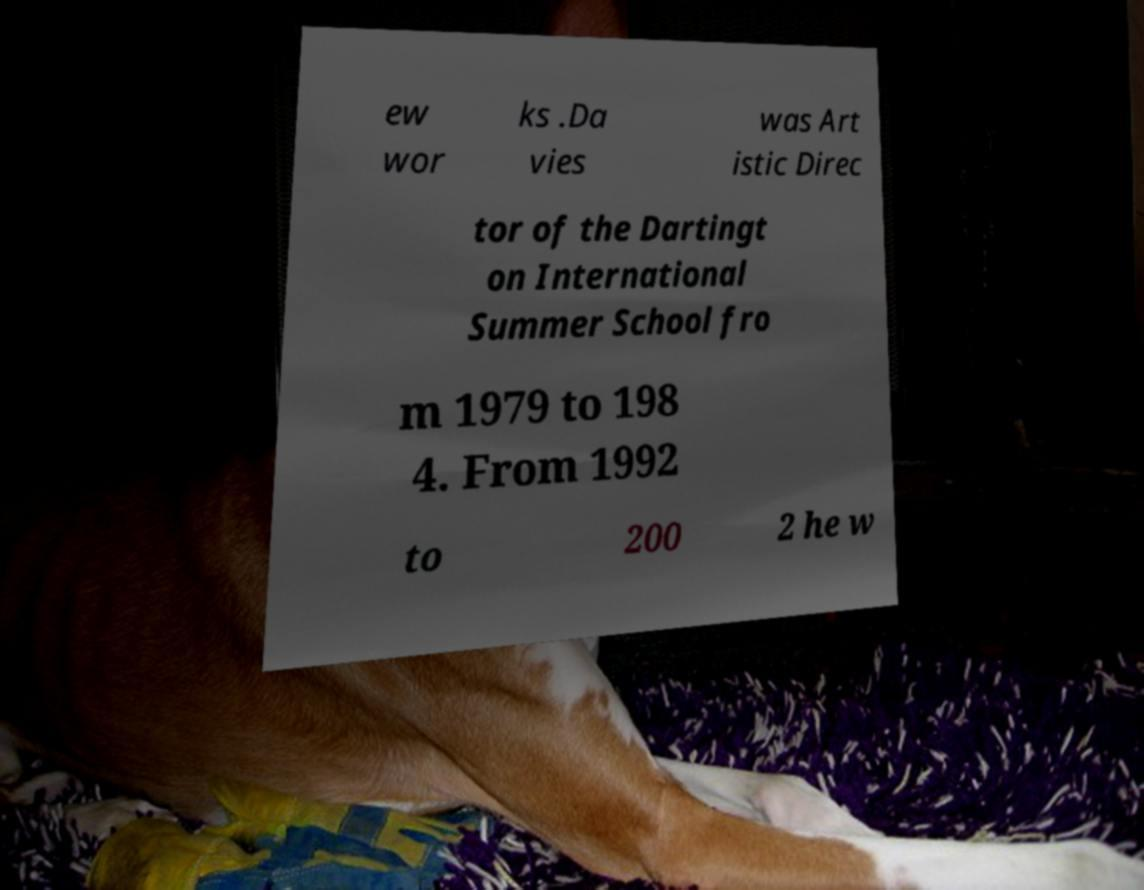Could you assist in decoding the text presented in this image and type it out clearly? ew wor ks .Da vies was Art istic Direc tor of the Dartingt on International Summer School fro m 1979 to 198 4. From 1992 to 200 2 he w 